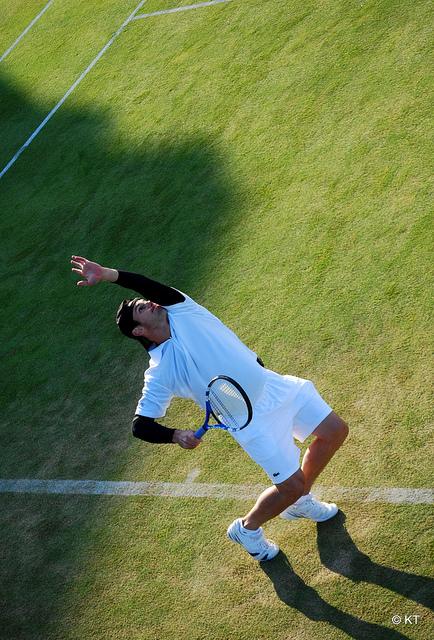What is the primary color in this picture?
Quick response, please. Green. What is the man holding?
Short answer required. Tennis racket. What sport is this?
Keep it brief. Tennis. 